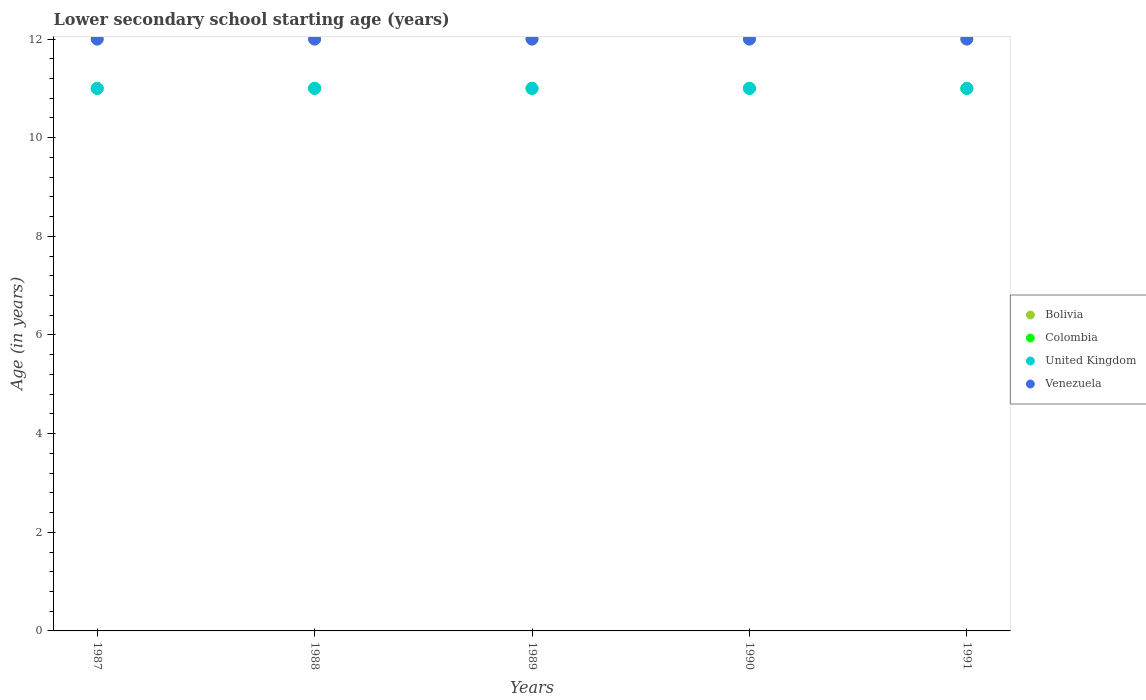How many different coloured dotlines are there?
Your response must be concise. 4. Is the number of dotlines equal to the number of legend labels?
Keep it short and to the point. Yes. Across all years, what is the maximum lower secondary school starting age of children in Venezuela?
Make the answer very short. 12. Across all years, what is the minimum lower secondary school starting age of children in United Kingdom?
Offer a terse response. 11. In which year was the lower secondary school starting age of children in United Kingdom minimum?
Offer a very short reply. 1987. What is the total lower secondary school starting age of children in United Kingdom in the graph?
Your answer should be very brief. 55. What is the difference between the lower secondary school starting age of children in Colombia in 1989 and the lower secondary school starting age of children in Bolivia in 1987?
Keep it short and to the point. -1. In the year 1991, what is the difference between the lower secondary school starting age of children in United Kingdom and lower secondary school starting age of children in Bolivia?
Give a very brief answer. -1. In how many years, is the lower secondary school starting age of children in Bolivia greater than 10.8 years?
Offer a very short reply. 5. Is the lower secondary school starting age of children in United Kingdom in 1989 less than that in 1990?
Provide a short and direct response. No. What is the difference between the highest and the lowest lower secondary school starting age of children in Colombia?
Offer a very short reply. 0. In how many years, is the lower secondary school starting age of children in United Kingdom greater than the average lower secondary school starting age of children in United Kingdom taken over all years?
Provide a short and direct response. 0. Is it the case that in every year, the sum of the lower secondary school starting age of children in Colombia and lower secondary school starting age of children in United Kingdom  is greater than the lower secondary school starting age of children in Bolivia?
Provide a succinct answer. Yes. How many years are there in the graph?
Offer a very short reply. 5. What is the difference between two consecutive major ticks on the Y-axis?
Provide a succinct answer. 2. Does the graph contain grids?
Make the answer very short. No. Where does the legend appear in the graph?
Give a very brief answer. Center right. How are the legend labels stacked?
Give a very brief answer. Vertical. What is the title of the graph?
Offer a very short reply. Lower secondary school starting age (years). Does "Togo" appear as one of the legend labels in the graph?
Give a very brief answer. No. What is the label or title of the X-axis?
Keep it short and to the point. Years. What is the label or title of the Y-axis?
Your response must be concise. Age (in years). What is the Age (in years) of Bolivia in 1987?
Give a very brief answer. 12. What is the Age (in years) in United Kingdom in 1987?
Keep it short and to the point. 11. What is the Age (in years) in Bolivia in 1988?
Provide a succinct answer. 12. What is the Age (in years) in Colombia in 1988?
Offer a very short reply. 11. What is the Age (in years) in United Kingdom in 1988?
Offer a terse response. 11. What is the Age (in years) in Venezuela in 1988?
Provide a short and direct response. 12. What is the Age (in years) in United Kingdom in 1989?
Your answer should be compact. 11. What is the Age (in years) in Colombia in 1990?
Provide a succinct answer. 11. What is the Age (in years) of Colombia in 1991?
Your answer should be very brief. 11. What is the Age (in years) in United Kingdom in 1991?
Provide a short and direct response. 11. Across all years, what is the maximum Age (in years) in United Kingdom?
Offer a terse response. 11. Across all years, what is the maximum Age (in years) of Venezuela?
Offer a terse response. 12. Across all years, what is the minimum Age (in years) of Bolivia?
Provide a succinct answer. 12. Across all years, what is the minimum Age (in years) in Colombia?
Your answer should be compact. 11. Across all years, what is the minimum Age (in years) of Venezuela?
Your answer should be very brief. 12. What is the total Age (in years) of Colombia in the graph?
Provide a succinct answer. 55. What is the total Age (in years) in United Kingdom in the graph?
Offer a terse response. 55. What is the difference between the Age (in years) in Colombia in 1987 and that in 1988?
Provide a short and direct response. 0. What is the difference between the Age (in years) of United Kingdom in 1987 and that in 1988?
Make the answer very short. 0. What is the difference between the Age (in years) of Venezuela in 1987 and that in 1988?
Your answer should be very brief. 0. What is the difference between the Age (in years) of Bolivia in 1987 and that in 1989?
Ensure brevity in your answer.  0. What is the difference between the Age (in years) of Bolivia in 1987 and that in 1990?
Give a very brief answer. 0. What is the difference between the Age (in years) of United Kingdom in 1987 and that in 1990?
Provide a short and direct response. 0. What is the difference between the Age (in years) of Venezuela in 1987 and that in 1990?
Offer a terse response. 0. What is the difference between the Age (in years) of United Kingdom in 1987 and that in 1991?
Offer a terse response. 0. What is the difference between the Age (in years) of Venezuela in 1987 and that in 1991?
Make the answer very short. 0. What is the difference between the Age (in years) in Bolivia in 1988 and that in 1989?
Your answer should be very brief. 0. What is the difference between the Age (in years) in Colombia in 1988 and that in 1989?
Make the answer very short. 0. What is the difference between the Age (in years) in Venezuela in 1988 and that in 1989?
Your answer should be compact. 0. What is the difference between the Age (in years) in Bolivia in 1988 and that in 1990?
Ensure brevity in your answer.  0. What is the difference between the Age (in years) of United Kingdom in 1988 and that in 1990?
Keep it short and to the point. 0. What is the difference between the Age (in years) in Venezuela in 1988 and that in 1991?
Your response must be concise. 0. What is the difference between the Age (in years) in Bolivia in 1989 and that in 1990?
Give a very brief answer. 0. What is the difference between the Age (in years) of Bolivia in 1989 and that in 1991?
Your answer should be compact. 0. What is the difference between the Age (in years) of United Kingdom in 1989 and that in 1991?
Your response must be concise. 0. What is the difference between the Age (in years) of Colombia in 1990 and that in 1991?
Your response must be concise. 0. What is the difference between the Age (in years) in United Kingdom in 1990 and that in 1991?
Your answer should be very brief. 0. What is the difference between the Age (in years) in Venezuela in 1990 and that in 1991?
Your response must be concise. 0. What is the difference between the Age (in years) in Bolivia in 1987 and the Age (in years) in Colombia in 1988?
Ensure brevity in your answer.  1. What is the difference between the Age (in years) of Bolivia in 1987 and the Age (in years) of United Kingdom in 1988?
Your answer should be very brief. 1. What is the difference between the Age (in years) in Bolivia in 1987 and the Age (in years) in Venezuela in 1988?
Make the answer very short. 0. What is the difference between the Age (in years) in United Kingdom in 1987 and the Age (in years) in Venezuela in 1988?
Your answer should be very brief. -1. What is the difference between the Age (in years) of United Kingdom in 1987 and the Age (in years) of Venezuela in 1989?
Provide a succinct answer. -1. What is the difference between the Age (in years) in Bolivia in 1987 and the Age (in years) in Colombia in 1990?
Ensure brevity in your answer.  1. What is the difference between the Age (in years) in Bolivia in 1987 and the Age (in years) in United Kingdom in 1990?
Your response must be concise. 1. What is the difference between the Age (in years) in Colombia in 1987 and the Age (in years) in United Kingdom in 1990?
Provide a short and direct response. 0. What is the difference between the Age (in years) in Colombia in 1987 and the Age (in years) in United Kingdom in 1991?
Offer a terse response. 0. What is the difference between the Age (in years) of Colombia in 1987 and the Age (in years) of Venezuela in 1991?
Keep it short and to the point. -1. What is the difference between the Age (in years) of Bolivia in 1988 and the Age (in years) of Colombia in 1989?
Your answer should be compact. 1. What is the difference between the Age (in years) of Bolivia in 1988 and the Age (in years) of United Kingdom in 1989?
Make the answer very short. 1. What is the difference between the Age (in years) in Colombia in 1988 and the Age (in years) in United Kingdom in 1989?
Offer a terse response. 0. What is the difference between the Age (in years) in Colombia in 1988 and the Age (in years) in Venezuela in 1989?
Offer a terse response. -1. What is the difference between the Age (in years) in United Kingdom in 1988 and the Age (in years) in Venezuela in 1989?
Your response must be concise. -1. What is the difference between the Age (in years) of Bolivia in 1988 and the Age (in years) of Colombia in 1990?
Your answer should be very brief. 1. What is the difference between the Age (in years) of Bolivia in 1988 and the Age (in years) of United Kingdom in 1990?
Give a very brief answer. 1. What is the difference between the Age (in years) in Colombia in 1988 and the Age (in years) in Venezuela in 1991?
Keep it short and to the point. -1. What is the difference between the Age (in years) of Bolivia in 1989 and the Age (in years) of Colombia in 1990?
Make the answer very short. 1. What is the difference between the Age (in years) in Colombia in 1989 and the Age (in years) in Venezuela in 1990?
Keep it short and to the point. -1. What is the difference between the Age (in years) in Colombia in 1989 and the Age (in years) in United Kingdom in 1991?
Ensure brevity in your answer.  0. What is the difference between the Age (in years) of Colombia in 1989 and the Age (in years) of Venezuela in 1991?
Keep it short and to the point. -1. What is the difference between the Age (in years) in United Kingdom in 1989 and the Age (in years) in Venezuela in 1991?
Make the answer very short. -1. What is the difference between the Age (in years) in Bolivia in 1990 and the Age (in years) in Colombia in 1991?
Your response must be concise. 1. What is the difference between the Age (in years) of Bolivia in 1990 and the Age (in years) of United Kingdom in 1991?
Your answer should be very brief. 1. What is the average Age (in years) in Colombia per year?
Make the answer very short. 11. What is the average Age (in years) of United Kingdom per year?
Give a very brief answer. 11. In the year 1987, what is the difference between the Age (in years) in Colombia and Age (in years) in Venezuela?
Provide a short and direct response. -1. In the year 1988, what is the difference between the Age (in years) in Bolivia and Age (in years) in United Kingdom?
Keep it short and to the point. 1. In the year 1988, what is the difference between the Age (in years) of Colombia and Age (in years) of Venezuela?
Give a very brief answer. -1. In the year 1989, what is the difference between the Age (in years) in Bolivia and Age (in years) in Colombia?
Make the answer very short. 1. In the year 1989, what is the difference between the Age (in years) in Bolivia and Age (in years) in United Kingdom?
Your response must be concise. 1. In the year 1989, what is the difference between the Age (in years) of Bolivia and Age (in years) of Venezuela?
Provide a succinct answer. 0. In the year 1989, what is the difference between the Age (in years) of Colombia and Age (in years) of United Kingdom?
Keep it short and to the point. 0. In the year 1989, what is the difference between the Age (in years) of Colombia and Age (in years) of Venezuela?
Provide a short and direct response. -1. In the year 1990, what is the difference between the Age (in years) in Bolivia and Age (in years) in United Kingdom?
Your answer should be very brief. 1. In the year 1990, what is the difference between the Age (in years) of Bolivia and Age (in years) of Venezuela?
Offer a terse response. 0. In the year 1990, what is the difference between the Age (in years) of Colombia and Age (in years) of Venezuela?
Provide a succinct answer. -1. In the year 1990, what is the difference between the Age (in years) of United Kingdom and Age (in years) of Venezuela?
Your answer should be compact. -1. In the year 1991, what is the difference between the Age (in years) of Colombia and Age (in years) of United Kingdom?
Your answer should be compact. 0. In the year 1991, what is the difference between the Age (in years) in Colombia and Age (in years) in Venezuela?
Give a very brief answer. -1. What is the ratio of the Age (in years) in Venezuela in 1987 to that in 1988?
Provide a succinct answer. 1. What is the ratio of the Age (in years) of United Kingdom in 1987 to that in 1989?
Offer a terse response. 1. What is the ratio of the Age (in years) of Venezuela in 1987 to that in 1989?
Provide a short and direct response. 1. What is the ratio of the Age (in years) of Bolivia in 1987 to that in 1990?
Give a very brief answer. 1. What is the ratio of the Age (in years) in Venezuela in 1987 to that in 1991?
Keep it short and to the point. 1. What is the ratio of the Age (in years) in Bolivia in 1988 to that in 1989?
Provide a succinct answer. 1. What is the ratio of the Age (in years) in United Kingdom in 1988 to that in 1989?
Make the answer very short. 1. What is the ratio of the Age (in years) of Venezuela in 1988 to that in 1989?
Your response must be concise. 1. What is the ratio of the Age (in years) of Colombia in 1988 to that in 1990?
Provide a succinct answer. 1. What is the ratio of the Age (in years) of Venezuela in 1988 to that in 1990?
Make the answer very short. 1. What is the ratio of the Age (in years) in Bolivia in 1988 to that in 1991?
Make the answer very short. 1. What is the ratio of the Age (in years) in Venezuela in 1989 to that in 1990?
Offer a very short reply. 1. What is the ratio of the Age (in years) of Colombia in 1989 to that in 1991?
Provide a short and direct response. 1. What is the ratio of the Age (in years) of Venezuela in 1989 to that in 1991?
Your answer should be very brief. 1. What is the ratio of the Age (in years) of Bolivia in 1990 to that in 1991?
Offer a terse response. 1. What is the ratio of the Age (in years) of United Kingdom in 1990 to that in 1991?
Make the answer very short. 1. What is the difference between the highest and the lowest Age (in years) of Colombia?
Give a very brief answer. 0. What is the difference between the highest and the lowest Age (in years) in Venezuela?
Provide a short and direct response. 0. 